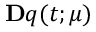<formula> <loc_0><loc_0><loc_500><loc_500>\mathbf q ( t ; \boldsymbol \mu )</formula> 